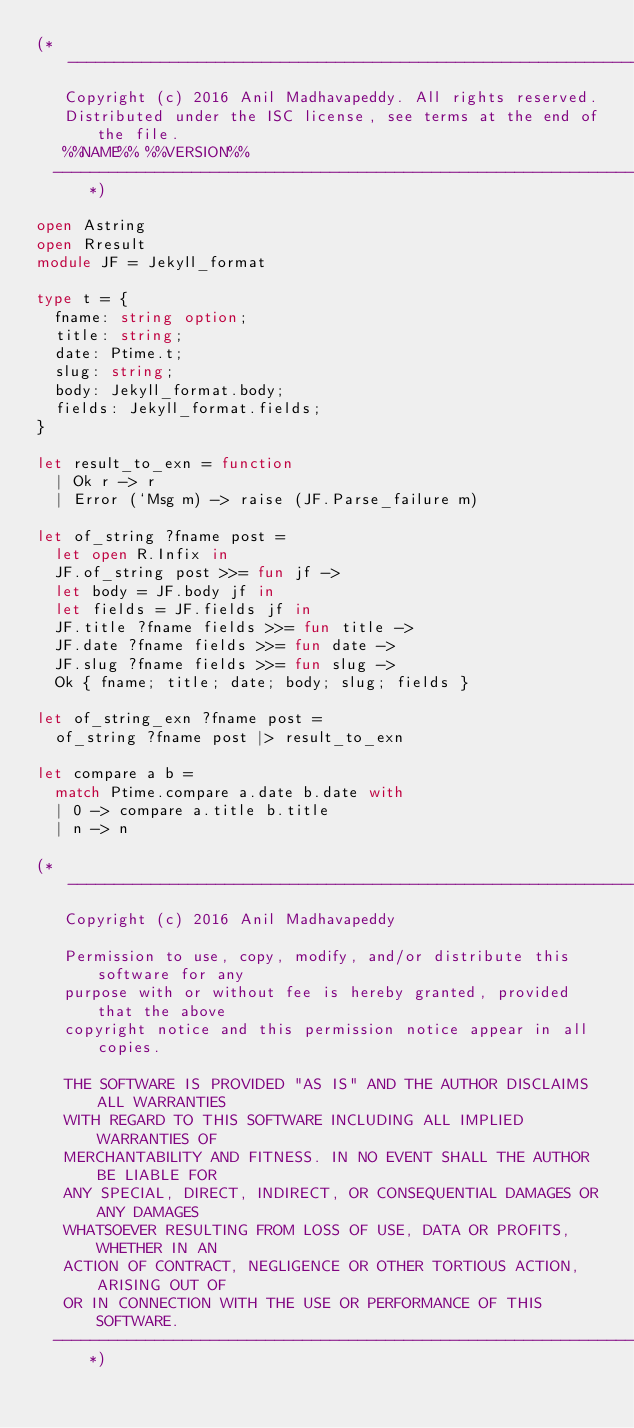<code> <loc_0><loc_0><loc_500><loc_500><_OCaml_>(*---------------------------------------------------------------------------
   Copyright (c) 2016 Anil Madhavapeddy. All rights reserved.
   Distributed under the ISC license, see terms at the end of the file.
   %%NAME%% %%VERSION%%
  ---------------------------------------------------------------------------*)

open Astring
open Rresult
module JF = Jekyll_format

type t = {
  fname: string option;
  title: string;
  date: Ptime.t;
  slug: string;
  body: Jekyll_format.body;
  fields: Jekyll_format.fields;
}

let result_to_exn = function
  | Ok r -> r
  | Error (`Msg m) -> raise (JF.Parse_failure m)

let of_string ?fname post =
  let open R.Infix in
  JF.of_string post >>= fun jf ->
  let body = JF.body jf in
  let fields = JF.fields jf in
  JF.title ?fname fields >>= fun title ->
  JF.date ?fname fields >>= fun date ->
  JF.slug ?fname fields >>= fun slug ->
  Ok { fname; title; date; body; slug; fields } 

let of_string_exn ?fname post =
  of_string ?fname post |> result_to_exn

let compare a b =
  match Ptime.compare a.date b.date with
  | 0 -> compare a.title b.title
  | n -> n

(*---------------------------------------------------------------------------
   Copyright (c) 2016 Anil Madhavapeddy

   Permission to use, copy, modify, and/or distribute this software for any
   purpose with or without fee is hereby granted, provided that the above
   copyright notice and this permission notice appear in all copies.

   THE SOFTWARE IS PROVIDED "AS IS" AND THE AUTHOR DISCLAIMS ALL WARRANTIES
   WITH REGARD TO THIS SOFTWARE INCLUDING ALL IMPLIED WARRANTIES OF
   MERCHANTABILITY AND FITNESS. IN NO EVENT SHALL THE AUTHOR BE LIABLE FOR
   ANY SPECIAL, DIRECT, INDIRECT, OR CONSEQUENTIAL DAMAGES OR ANY DAMAGES
   WHATSOEVER RESULTING FROM LOSS OF USE, DATA OR PROFITS, WHETHER IN AN
   ACTION OF CONTRACT, NEGLIGENCE OR OTHER TORTIOUS ACTION, ARISING OUT OF
   OR IN CONNECTION WITH THE USE OR PERFORMANCE OF THIS SOFTWARE.
  ---------------------------------------------------------------------------*)
</code> 